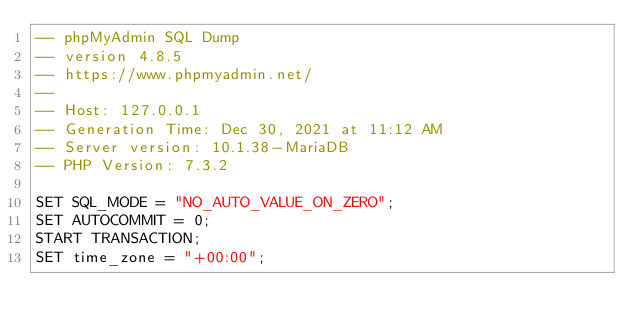Convert code to text. <code><loc_0><loc_0><loc_500><loc_500><_SQL_>-- phpMyAdmin SQL Dump
-- version 4.8.5
-- https://www.phpmyadmin.net/
--
-- Host: 127.0.0.1
-- Generation Time: Dec 30, 2021 at 11:12 AM
-- Server version: 10.1.38-MariaDB
-- PHP Version: 7.3.2

SET SQL_MODE = "NO_AUTO_VALUE_ON_ZERO";
SET AUTOCOMMIT = 0;
START TRANSACTION;
SET time_zone = "+00:00";

</code> 